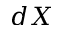<formula> <loc_0><loc_0><loc_500><loc_500>d X</formula> 